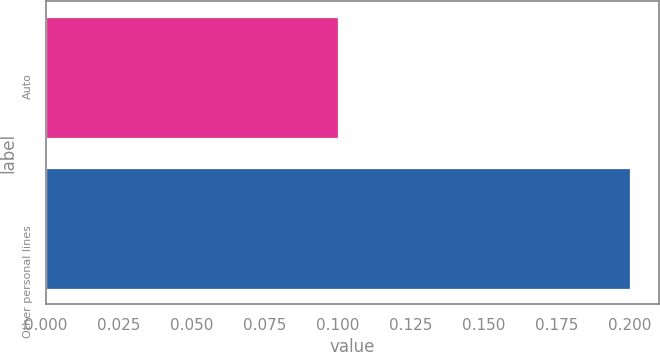Convert chart to OTSL. <chart><loc_0><loc_0><loc_500><loc_500><bar_chart><fcel>Auto<fcel>Other personal lines<nl><fcel>0.1<fcel>0.2<nl></chart> 